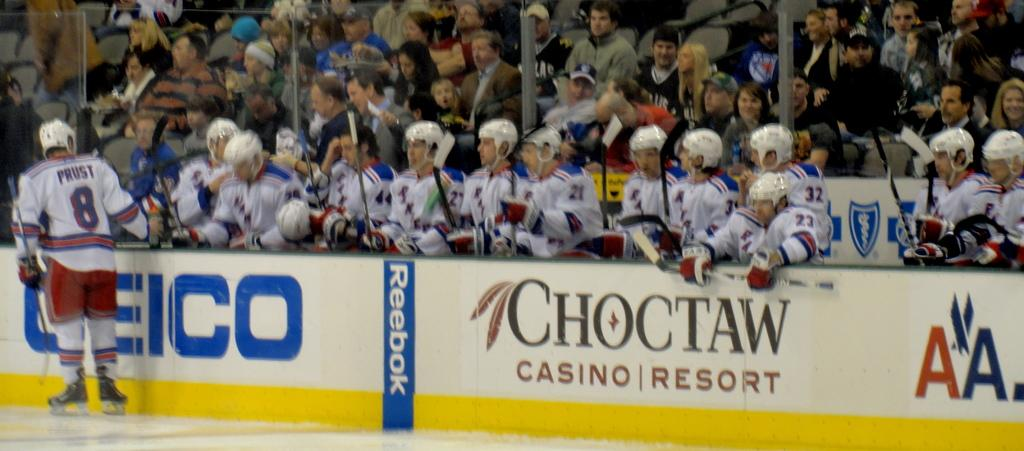<image>
Summarize the visual content of the image. the word Choctaw is under the hockey players 